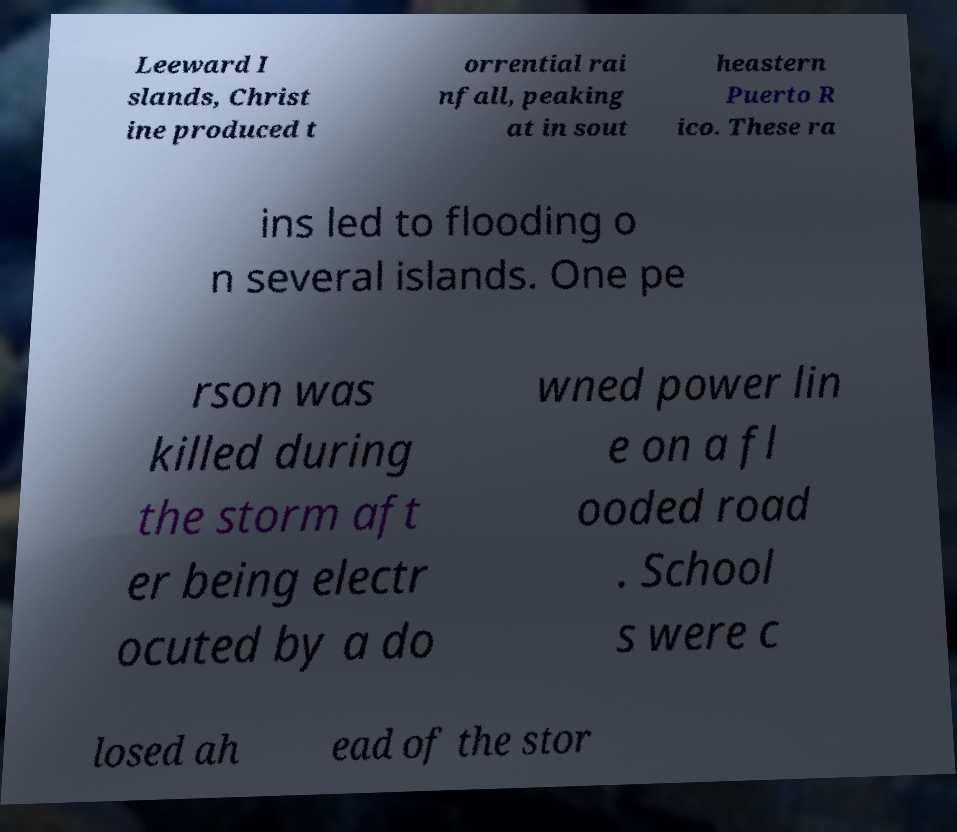There's text embedded in this image that I need extracted. Can you transcribe it verbatim? Leeward I slands, Christ ine produced t orrential rai nfall, peaking at in sout heastern Puerto R ico. These ra ins led to flooding o n several islands. One pe rson was killed during the storm aft er being electr ocuted by a do wned power lin e on a fl ooded road . School s were c losed ah ead of the stor 